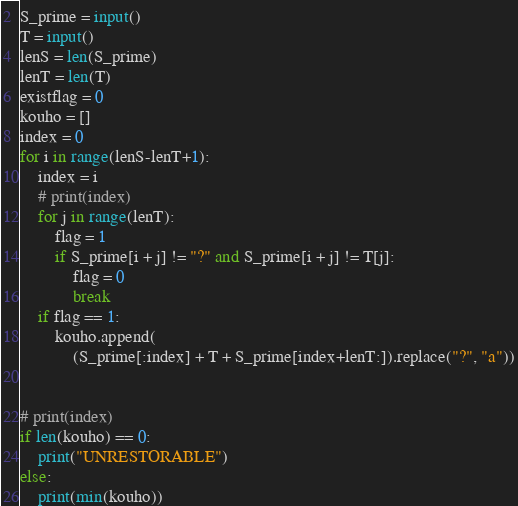<code> <loc_0><loc_0><loc_500><loc_500><_Python_>S_prime = input()
T = input()
lenS = len(S_prime)
lenT = len(T)
existflag = 0
kouho = []
index = 0
for i in range(lenS-lenT+1):
    index = i
    # print(index)
    for j in range(lenT):
        flag = 1
        if S_prime[i + j] != "?" and S_prime[i + j] != T[j]:
            flag = 0
            break
    if flag == 1:
        kouho.append(
            (S_prime[:index] + T + S_prime[index+lenT:]).replace("?", "a"))


# print(index)
if len(kouho) == 0:
    print("UNRESTORABLE")
else:
    print(min(kouho))
</code> 